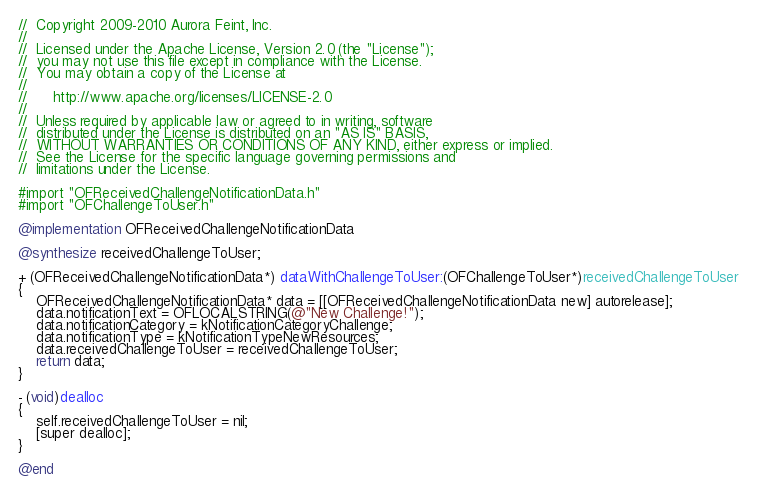Convert code to text. <code><loc_0><loc_0><loc_500><loc_500><_ObjectiveC_>//  Copyright 2009-2010 Aurora Feint, Inc.
// 
//  Licensed under the Apache License, Version 2.0 (the "License");
//  you may not use this file except in compliance with the License.
//  You may obtain a copy of the License at
//  
//  	http://www.apache.org/licenses/LICENSE-2.0
//  	
//  Unless required by applicable law or agreed to in writing, software
//  distributed under the License is distributed on an "AS IS" BASIS,
//  WITHOUT WARRANTIES OR CONDITIONS OF ANY KIND, either express or implied.
//  See the License for the specific language governing permissions and
//  limitations under the License.

#import "OFReceivedChallengeNotificationData.h"
#import "OFChallengeToUser.h"

@implementation OFReceivedChallengeNotificationData

@synthesize receivedChallengeToUser;

+ (OFReceivedChallengeNotificationData*) dataWithChallengeToUser:(OFChallengeToUser*)receivedChallengeToUser
{
	OFReceivedChallengeNotificationData* data = [[OFReceivedChallengeNotificationData new] autorelease];
	data.notificationText = OFLOCALSTRING(@"New Challenge!");
	data.notificationCategory = kNotificationCategoryChallenge;
	data.notificationType = kNotificationTypeNewResources;
	data.receivedChallengeToUser = receivedChallengeToUser;
	return data;
}

- (void)dealloc
{
	self.receivedChallengeToUser = nil;
	[super dealloc];
}

@end
</code> 